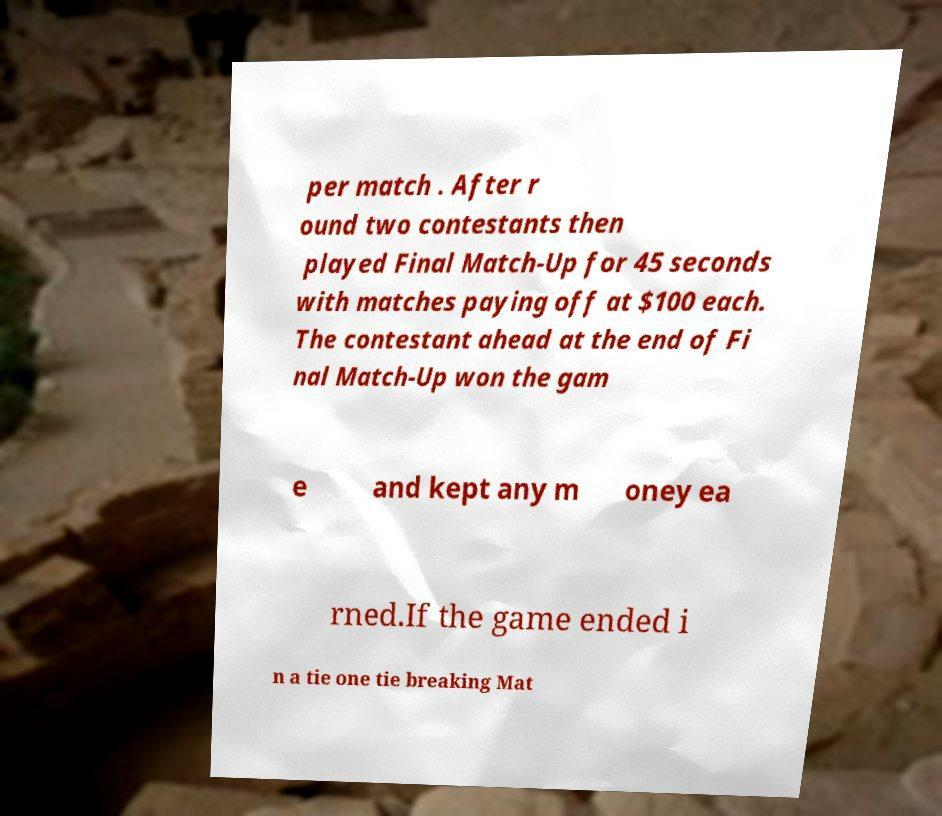Please read and relay the text visible in this image. What does it say? per match . After r ound two contestants then played Final Match-Up for 45 seconds with matches paying off at $100 each. The contestant ahead at the end of Fi nal Match-Up won the gam e and kept any m oney ea rned.If the game ended i n a tie one tie breaking Mat 